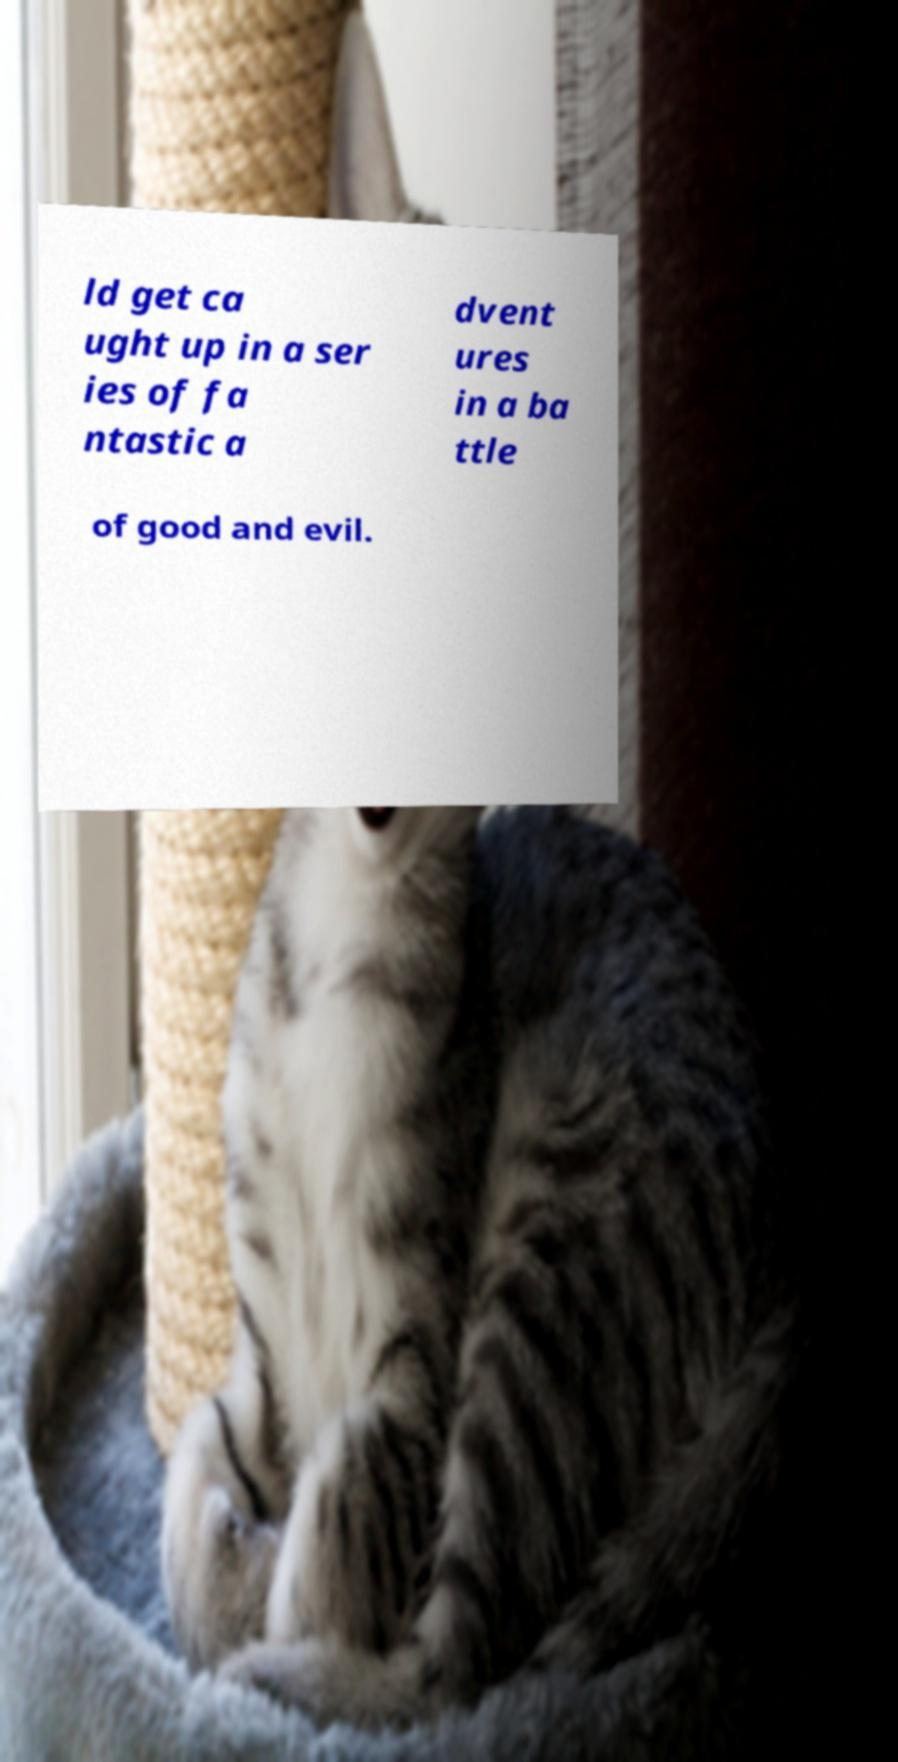For documentation purposes, I need the text within this image transcribed. Could you provide that? ld get ca ught up in a ser ies of fa ntastic a dvent ures in a ba ttle of good and evil. 